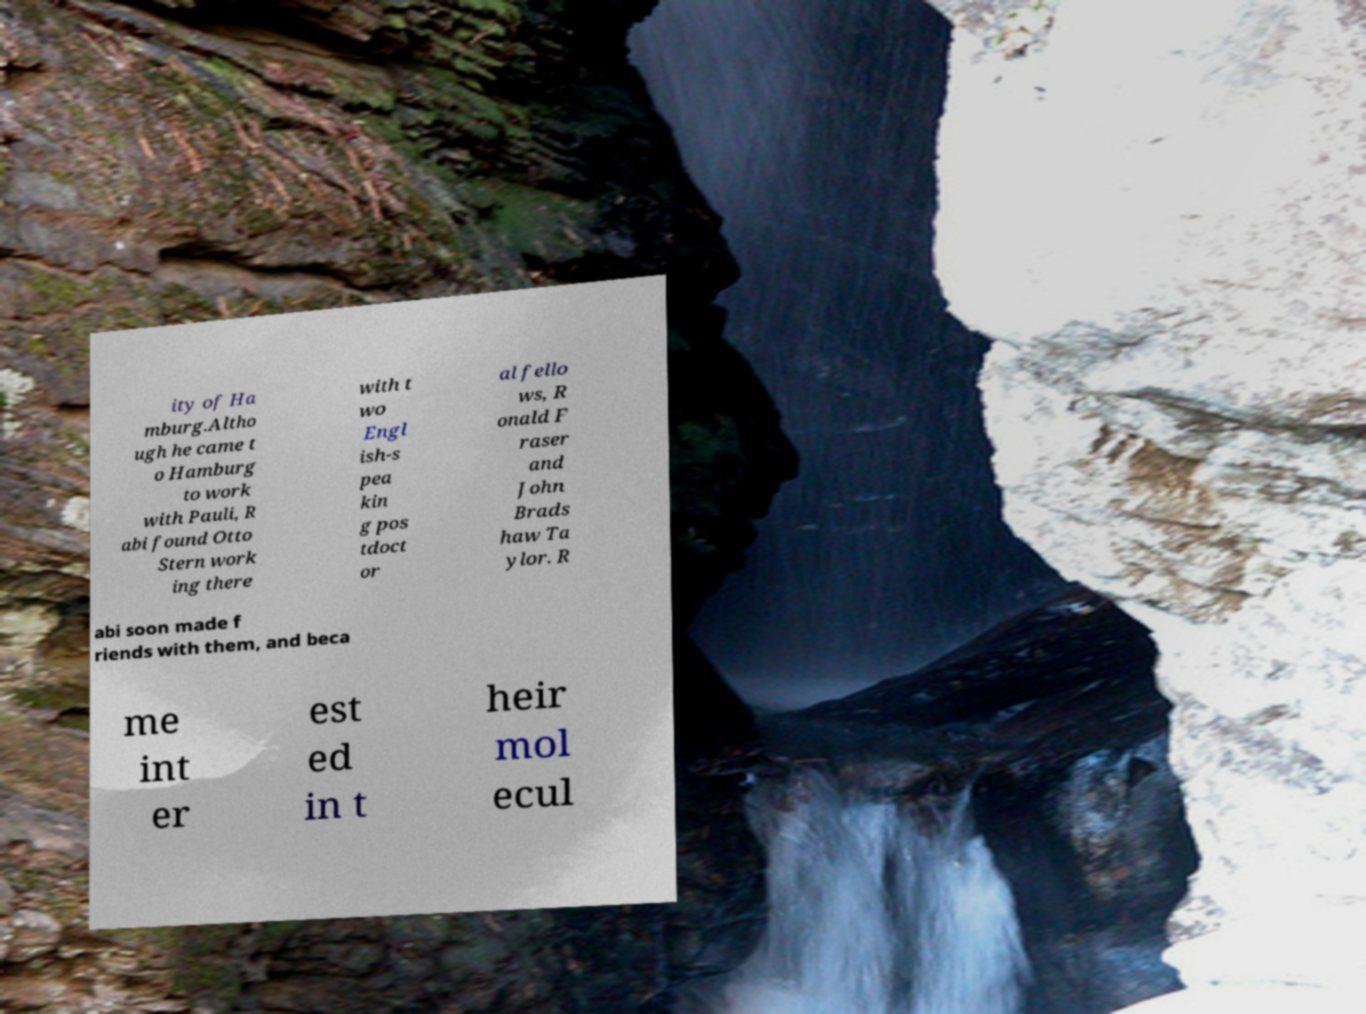There's text embedded in this image that I need extracted. Can you transcribe it verbatim? ity of Ha mburg.Altho ugh he came t o Hamburg to work with Pauli, R abi found Otto Stern work ing there with t wo Engl ish-s pea kin g pos tdoct or al fello ws, R onald F raser and John Brads haw Ta ylor. R abi soon made f riends with them, and beca me int er est ed in t heir mol ecul 